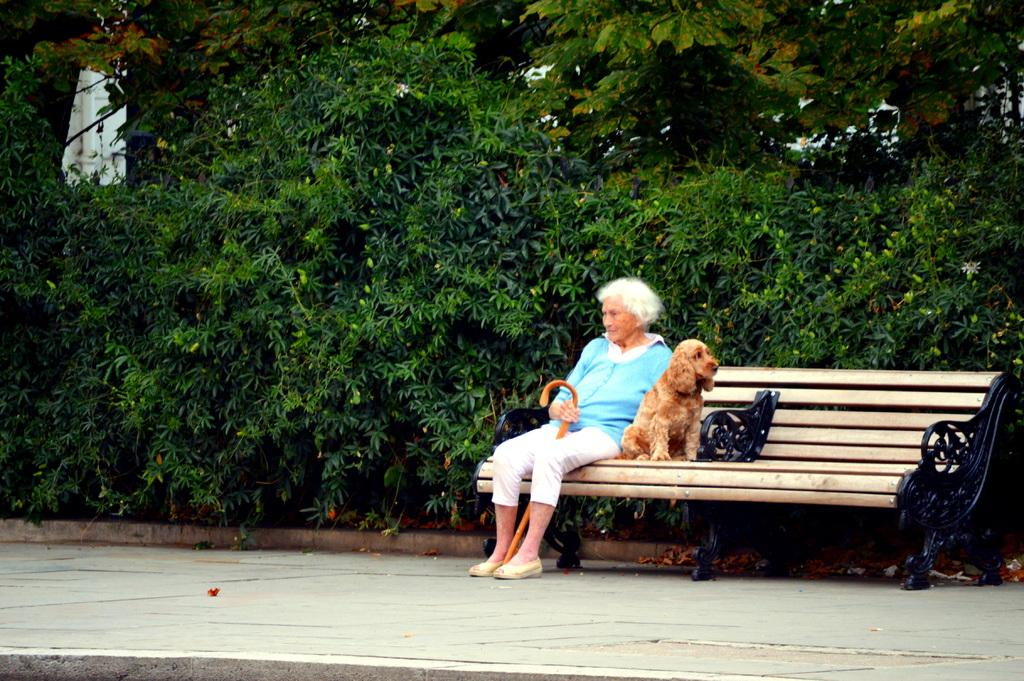Who is present in the image? There is a woman and a dog in the image. What are the woman and the dog doing in the image? The woman and the dog are sitting on a bench. What can be seen in the background of the image? There are plants and trees in the background of the image. What type of spy equipment can be seen in the image? There is no spy equipment present in the image. How many bikes are visible in the image? There are no bikes visible in the image. 